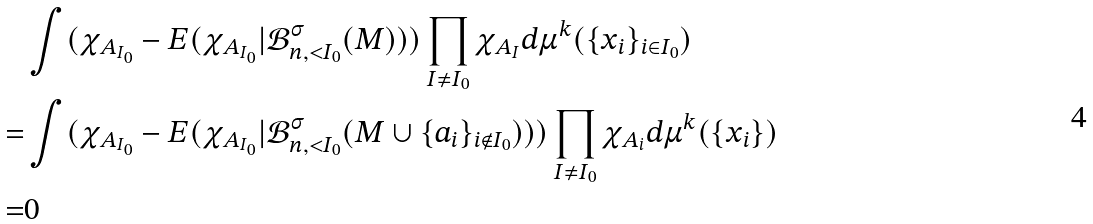Convert formula to latex. <formula><loc_0><loc_0><loc_500><loc_500>& \int ( \chi _ { A _ { I _ { 0 } } } - E ( \chi _ { A _ { I _ { 0 } } } | \mathcal { B } _ { n , { < } I _ { 0 } } ^ { \sigma } ( M ) ) ) \prod _ { I \neq I _ { 0 } } \chi _ { A _ { I } } d \mu ^ { k } ( \{ x _ { i } \} _ { i \in I _ { 0 } } ) \\ = & \int ( \chi _ { A _ { I _ { 0 } } } - E ( \chi _ { A _ { I _ { 0 } } } | \mathcal { B } _ { n , { < } I _ { 0 } } ^ { \sigma } ( M \cup \{ a _ { i } \} _ { i \not \in I _ { 0 } } ) ) ) \prod _ { I \neq I _ { 0 } } \chi _ { A _ { i } } d \mu ^ { k } ( \{ x _ { i } \} ) \\ = & 0</formula> 